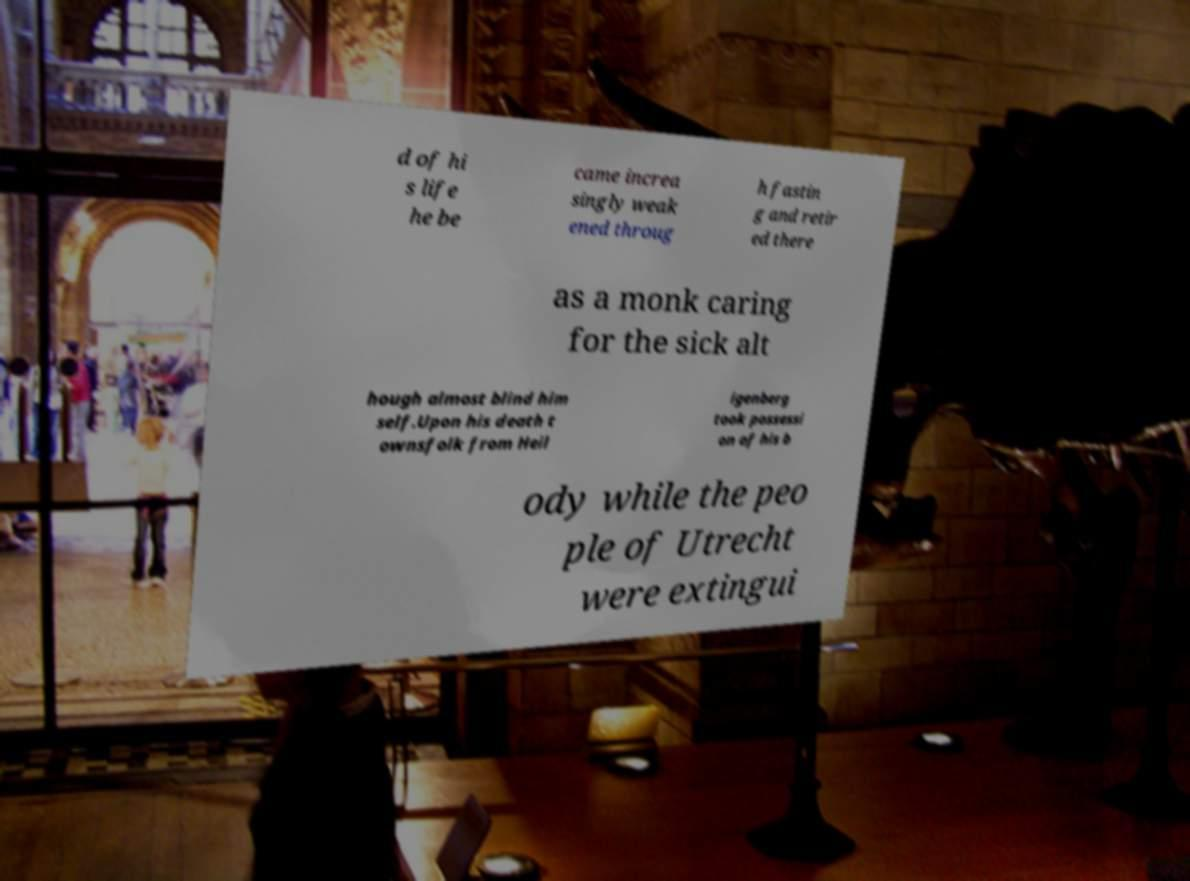What messages or text are displayed in this image? I need them in a readable, typed format. d of hi s life he be came increa singly weak ened throug h fastin g and retir ed there as a monk caring for the sick alt hough almost blind him self.Upon his death t ownsfolk from Heil igenberg took possessi on of his b ody while the peo ple of Utrecht were extingui 